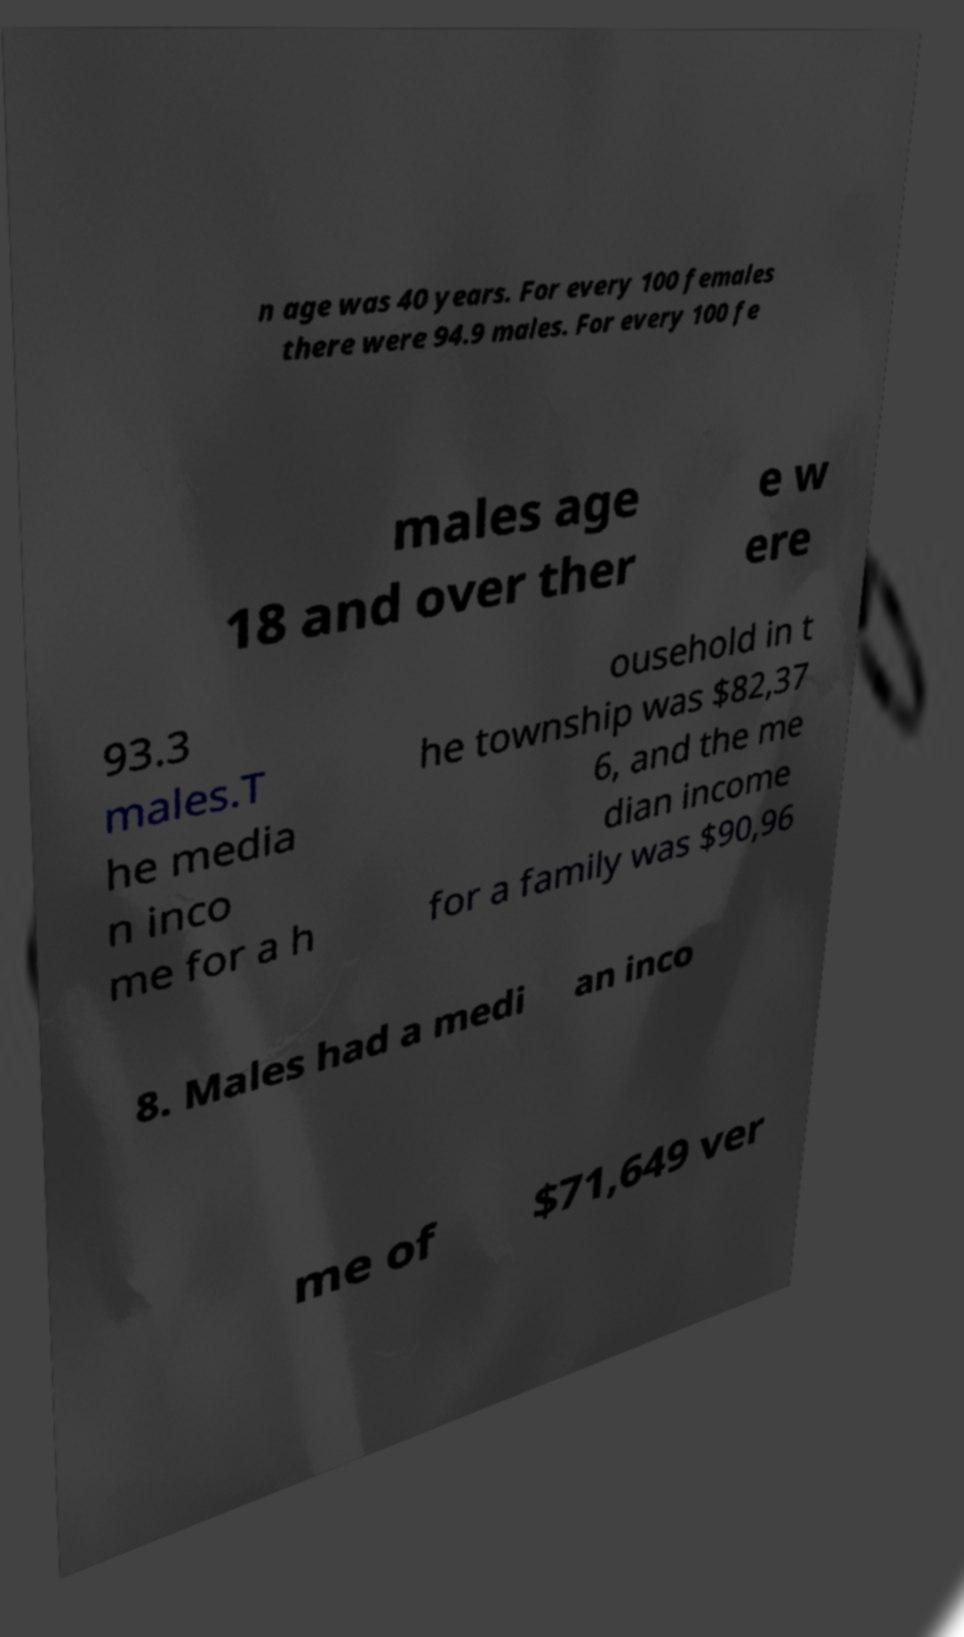For documentation purposes, I need the text within this image transcribed. Could you provide that? n age was 40 years. For every 100 females there were 94.9 males. For every 100 fe males age 18 and over ther e w ere 93.3 males.T he media n inco me for a h ousehold in t he township was $82,37 6, and the me dian income for a family was $90,96 8. Males had a medi an inco me of $71,649 ver 